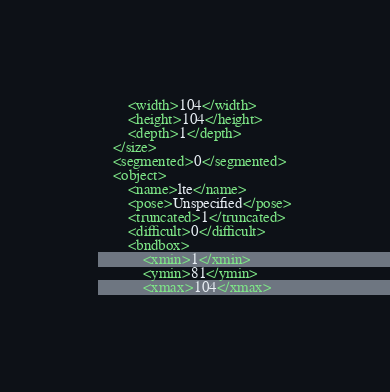Convert code to text. <code><loc_0><loc_0><loc_500><loc_500><_XML_>		<width>104</width>
		<height>104</height>
		<depth>1</depth>
	</size>
	<segmented>0</segmented>
	<object>
		<name>lte</name>
		<pose>Unspecified</pose>
		<truncated>1</truncated>
		<difficult>0</difficult>
		<bndbox>
			<xmin>1</xmin>
			<ymin>81</ymin>
			<xmax>104</xmax></code> 